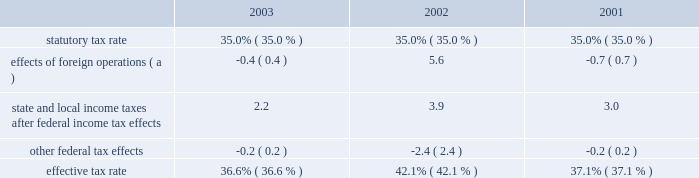Expenditures and acquisitions of leased properties are funded by the original contributor of the assets , but no change in ownership interest may result from these contributions .
An excess of ashland funded improvements over marathon funded improvements results in a net gain and an excess of marathon funded improvements over ashland funded improvements results in a net loss .
Cost of revenues increased by $ 8.718 billion in 2003 from 2002 and $ 367 million in 2002 from 2001 .
The increases in the oerb segment were primarily a result of higher natural gas and liquid hydrocarbon costs .
The increases in the rm&t segment primarily reflected higher acquisition costs for crude oil , refined products , refinery charge and blend feedstocks and increased manufacturing expenses .
Selling , general and administrative expenses increased by $ 107 million in 2003 from 2002 and $ 125 million in 2002 from 2001 .
The increase in 2003 was primarily a result of increased employee benefits ( caused by increased pension expense resulting from changes in actuarial assumptions and a decrease in realized returns on plan assets ) and other employee related costs .
Also , marathon changed assumptions in the health care cost trend rate from 7.5% ( 7.5 % ) to 10% ( 10 % ) , resulting in higher retiree health care costs .
Additionally , during 2003 , marathon recorded a charge of $ 24 million related to organizational and business process changes .
The increase in 2002 primarily reflected increased employee related costs .
Inventory market valuation reserve is established to reduce the cost basis of inventories to current market value .
The 2002 results of operations include credits to income from operations of $ 71 million , reversing the imv reserve at december 31 , 2001 .
For additional information on this adjustment , see 201cmanagement 2019s discussion and analysis of critical accounting estimates 2013 net realizable value of inventories 201d on page 31 .
Net interest and other financial costs decreased by $ 82 million in 2003 from 2002 , following an increase of $ 96 million in 2002 from 2001 .
The decrease in 2003 is primarily due to an increase in capitalized interest related to increased long-term construction projects , the favorable effect of interest rate swaps , the favorable effect of interest on tax deficiencies and increased interest income on investments .
The increase in 2002 was primarily due to higher average debt levels resulting from acquisitions and the separation .
Additionally , included in net interest and other financing costs are foreign currency gains of $ 13 million and $ 8 million for 2003 and 2002 and losses of $ 5 million for 2001 .
Loss from early extinguishment of debt in 2002 was attributable to the retirement of $ 337 million aggregate principal amount of debt , resulting in a loss of $ 53 million .
As a result of the adoption of statement of financial accounting standards no .
145 201crescission of fasb statements no .
4 , 44 , and 64 , amendment of fasb statement no .
13 , and technical corrections 201d ( 201csfas no .
145 201d ) , the loss from early extinguishment of debt that was previously reported as an extraordinary item ( net of taxes of $ 20 million ) has been reclassified into income before income taxes .
The adoption of sfas no .
145 had no impact on net income for 2002 .
Minority interest in income of map , which represents ashland 2019s 38 percent ownership interest , increased by $ 129 million in 2003 from 2002 , following a decrease of $ 531 million in 2002 from 2001 .
Map income was higher in 2003 compared to 2002 as discussed below in the rm&t segment .
Map income was significantly lower in 2002 compared to 2001 as discussed below in the rm&t segment .
Provision for income taxes increased by $ 215 million in 2003 from 2002 , following a decrease of $ 458 million in 2002 from 2001 , primarily due to $ 720 million increase and $ 1.356 billion decrease in income before income taxes .
The effective tax rate for 2003 was 36.6% ( 36.6 % ) compared to 42.1% ( 42.1 % ) and 37.1% ( 37.1 % ) for 2002 and 2001 .
The higher rate in 2002 was due to the united kingdom enactment of a supplementary 10 percent tax on profits from the north sea oil and gas production , retroactively effective to april 17 , 2002 .
In 2002 , marathon recognized a one-time noncash deferred tax adjustment of $ 61 million as a result of the rate increase .
The following is an analysis of the effective tax rate for the periods presented: .
( a ) the deferred tax effect related to the enactment of a supplemental tax in the u.k .
Increased the effective tax rate 7.0 percent in 2002. .
By how much did the effective tax rate decrease from 2002 to 2003? 
Computations: (36.6% - 42.1%)
Answer: -0.055. Expenditures and acquisitions of leased properties are funded by the original contributor of the assets , but no change in ownership interest may result from these contributions .
An excess of ashland funded improvements over marathon funded improvements results in a net gain and an excess of marathon funded improvements over ashland funded improvements results in a net loss .
Cost of revenues increased by $ 8.718 billion in 2003 from 2002 and $ 367 million in 2002 from 2001 .
The increases in the oerb segment were primarily a result of higher natural gas and liquid hydrocarbon costs .
The increases in the rm&t segment primarily reflected higher acquisition costs for crude oil , refined products , refinery charge and blend feedstocks and increased manufacturing expenses .
Selling , general and administrative expenses increased by $ 107 million in 2003 from 2002 and $ 125 million in 2002 from 2001 .
The increase in 2003 was primarily a result of increased employee benefits ( caused by increased pension expense resulting from changes in actuarial assumptions and a decrease in realized returns on plan assets ) and other employee related costs .
Also , marathon changed assumptions in the health care cost trend rate from 7.5% ( 7.5 % ) to 10% ( 10 % ) , resulting in higher retiree health care costs .
Additionally , during 2003 , marathon recorded a charge of $ 24 million related to organizational and business process changes .
The increase in 2002 primarily reflected increased employee related costs .
Inventory market valuation reserve is established to reduce the cost basis of inventories to current market value .
The 2002 results of operations include credits to income from operations of $ 71 million , reversing the imv reserve at december 31 , 2001 .
For additional information on this adjustment , see 201cmanagement 2019s discussion and analysis of critical accounting estimates 2013 net realizable value of inventories 201d on page 31 .
Net interest and other financial costs decreased by $ 82 million in 2003 from 2002 , following an increase of $ 96 million in 2002 from 2001 .
The decrease in 2003 is primarily due to an increase in capitalized interest related to increased long-term construction projects , the favorable effect of interest rate swaps , the favorable effect of interest on tax deficiencies and increased interest income on investments .
The increase in 2002 was primarily due to higher average debt levels resulting from acquisitions and the separation .
Additionally , included in net interest and other financing costs are foreign currency gains of $ 13 million and $ 8 million for 2003 and 2002 and losses of $ 5 million for 2001 .
Loss from early extinguishment of debt in 2002 was attributable to the retirement of $ 337 million aggregate principal amount of debt , resulting in a loss of $ 53 million .
As a result of the adoption of statement of financial accounting standards no .
145 201crescission of fasb statements no .
4 , 44 , and 64 , amendment of fasb statement no .
13 , and technical corrections 201d ( 201csfas no .
145 201d ) , the loss from early extinguishment of debt that was previously reported as an extraordinary item ( net of taxes of $ 20 million ) has been reclassified into income before income taxes .
The adoption of sfas no .
145 had no impact on net income for 2002 .
Minority interest in income of map , which represents ashland 2019s 38 percent ownership interest , increased by $ 129 million in 2003 from 2002 , following a decrease of $ 531 million in 2002 from 2001 .
Map income was higher in 2003 compared to 2002 as discussed below in the rm&t segment .
Map income was significantly lower in 2002 compared to 2001 as discussed below in the rm&t segment .
Provision for income taxes increased by $ 215 million in 2003 from 2002 , following a decrease of $ 458 million in 2002 from 2001 , primarily due to $ 720 million increase and $ 1.356 billion decrease in income before income taxes .
The effective tax rate for 2003 was 36.6% ( 36.6 % ) compared to 42.1% ( 42.1 % ) and 37.1% ( 37.1 % ) for 2002 and 2001 .
The higher rate in 2002 was due to the united kingdom enactment of a supplementary 10 percent tax on profits from the north sea oil and gas production , retroactively effective to april 17 , 2002 .
In 2002 , marathon recognized a one-time noncash deferred tax adjustment of $ 61 million as a result of the rate increase .
The following is an analysis of the effective tax rate for the periods presented: .
( a ) the deferred tax effect related to the enactment of a supplemental tax in the u.k .
Increased the effective tax rate 7.0 percent in 2002. .
What was the change in the effective tax rate between 2003 and 2002? 
Computations: (36.6 - 42.1)
Answer: -5.5. 